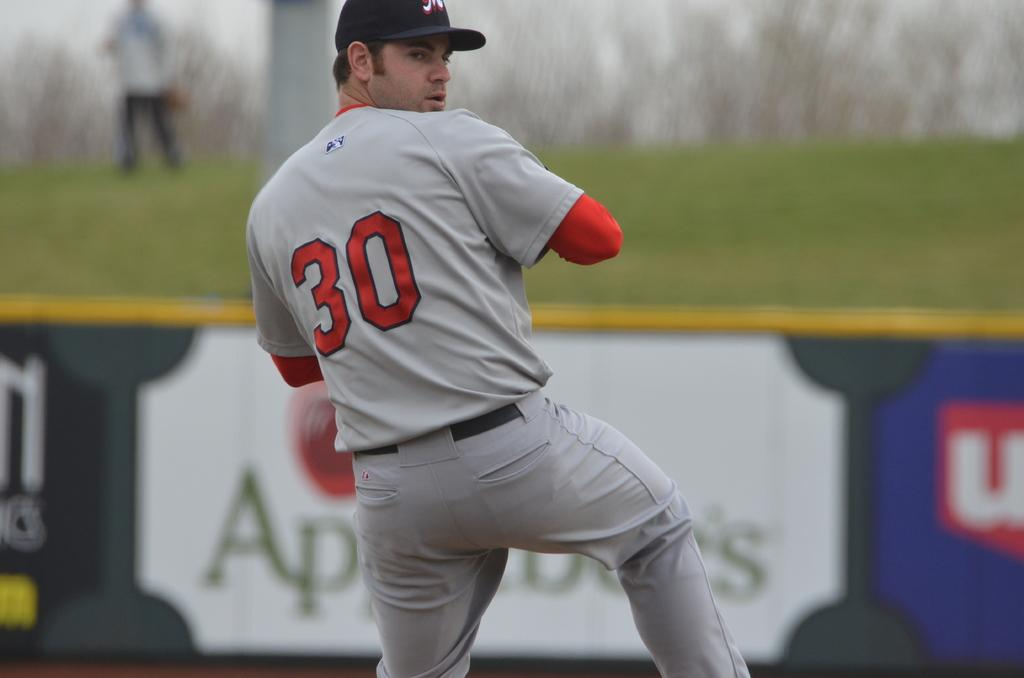<image>
Write a terse but informative summary of the picture. a baseball player with the number 30 on his jersey 